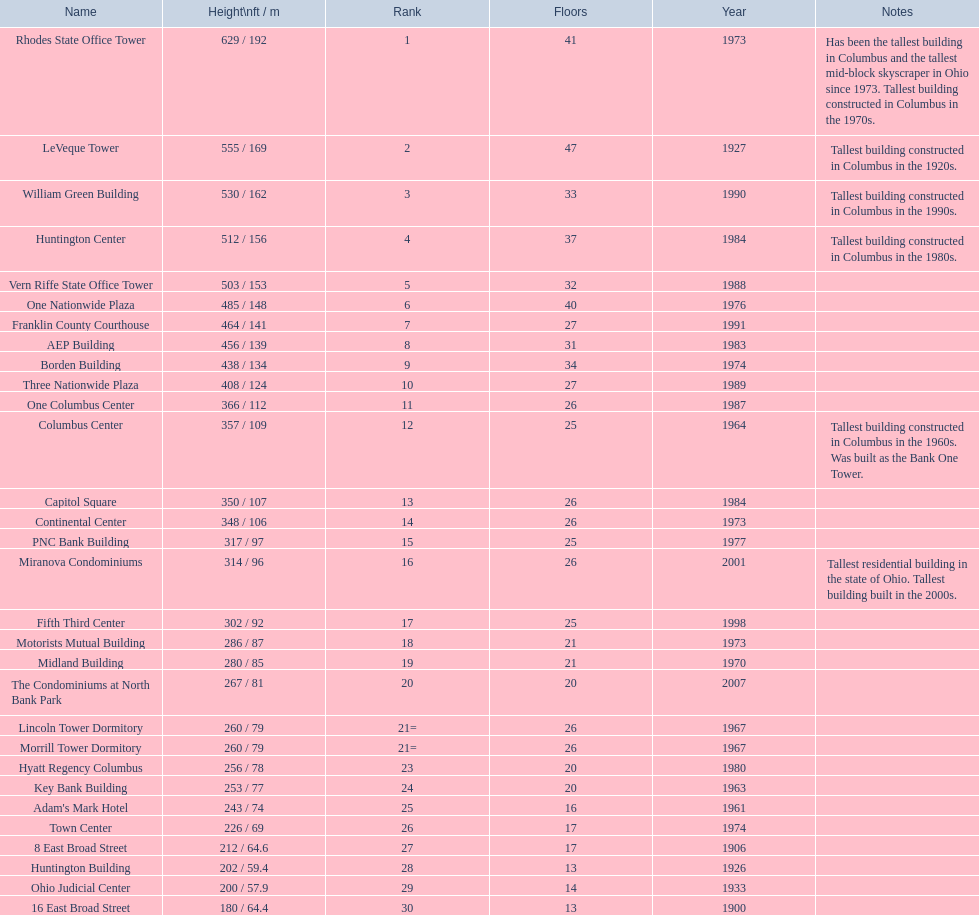How tall is the aep building? 456 / 139. How tall is the one columbus center? 366 / 112. Of these two buildings, which is taller? AEP Building. 